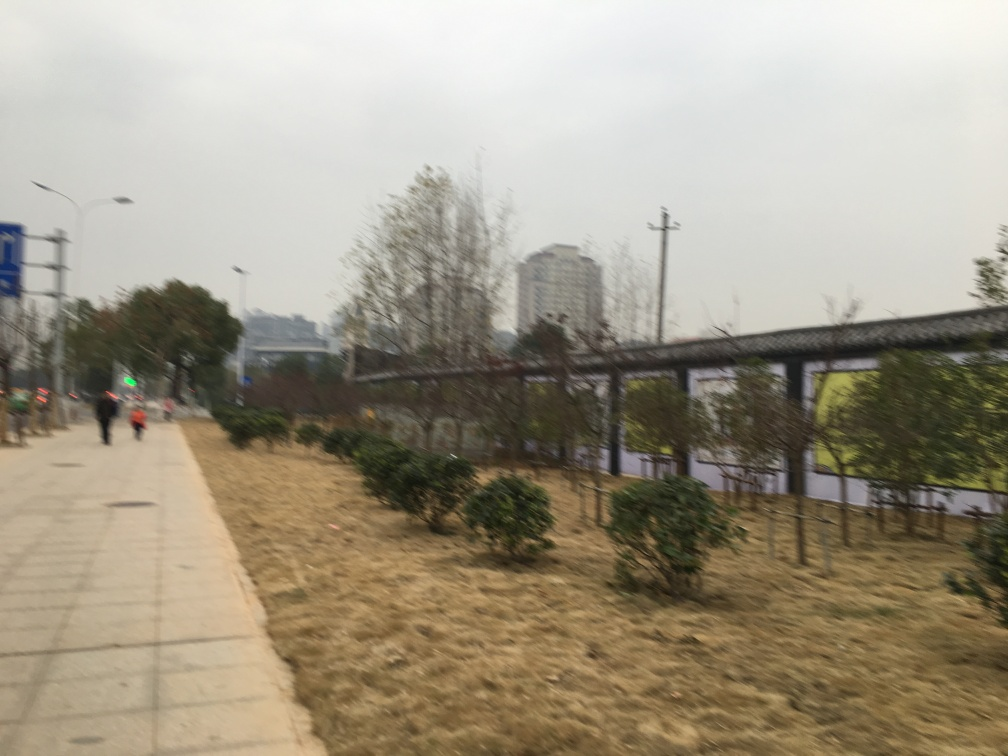How might the weather have affected the visibility and color saturation in this image? The overcast sky suggests a lack of direct sunlight, which can lead to subdued colors and lower contrast in the image, making the colors appear less vibrant and the details less pronounced. 